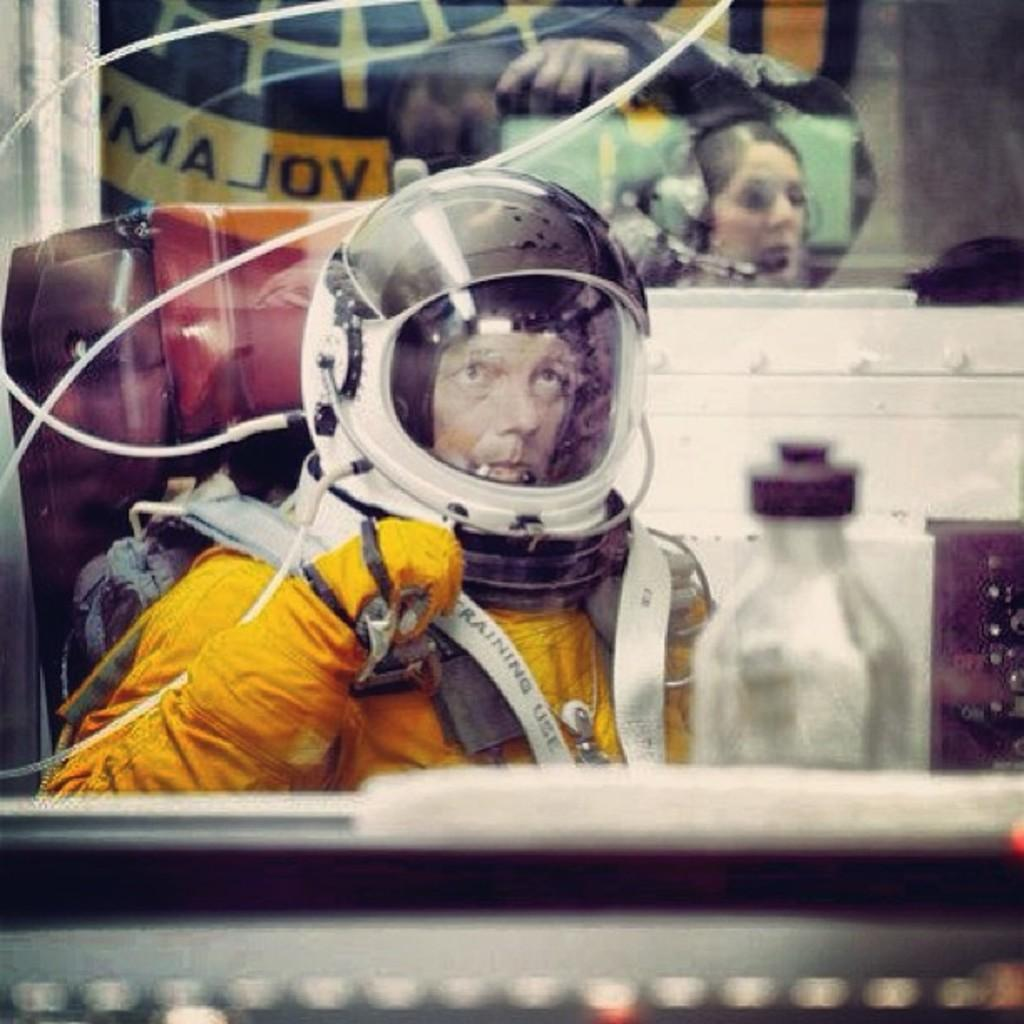What is the main subject of the picture? The main subject of the picture is an astronaut. What color is the astronaut's suit? The astronaut is wearing a yellow suit. What is the color of the astronaut's helmet? The astronaut is wearing a white helmet. What is the astronaut doing in the picture? The astronaut is sitting on a chair. What can be seen in the image besides the astronaut? There is a big glass and a water bottle visible in the image. What type of writing can be seen on the astronaut's suit? There is no writing visible on the astronaut's suit in the image. What kind of beast is present in the image? There are no beasts present in the image; it features an astronaut sitting on a chair with a big glass and a water bottle. 